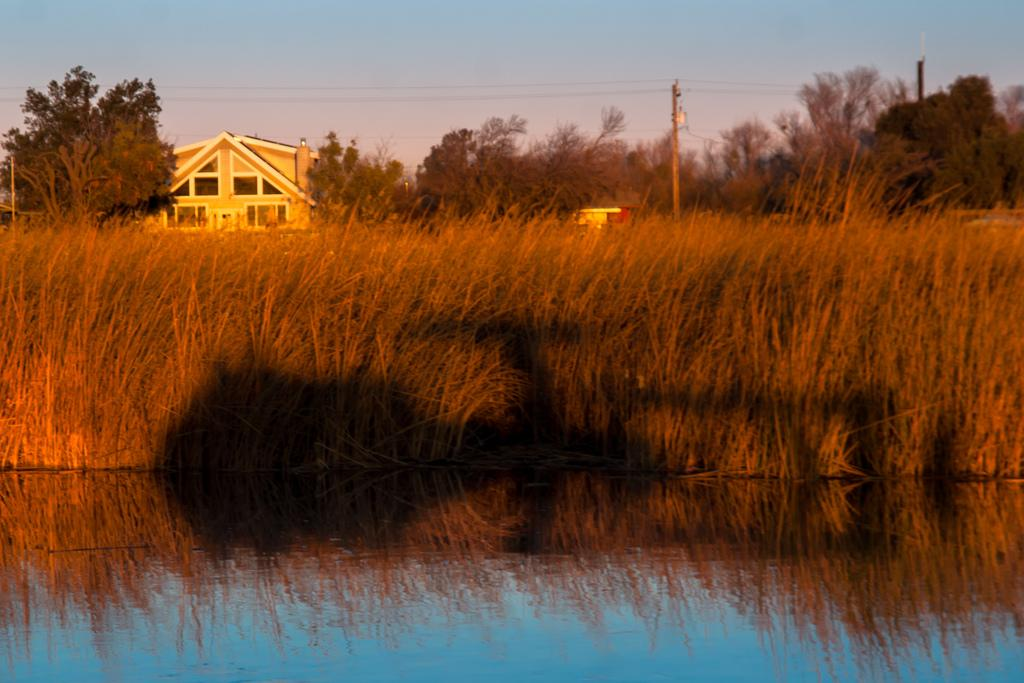What type of structure is visible in the image? There is a building in the image. What natural elements can be seen in the image? There are trees and plants in the water visible in the image. What are the poles used for in the image? The purpose of the poles in the image is not specified, but they could be used for various purposes such as supporting structures or signs. How would you describe the sky in the image? The sky is blue and cloudy in the image. Can you tell me how many experts are present in the image? There is no mention of experts in the image, so it is not possible to determine their presence or number. What type of parcel is floating in the water in the image? There is no parcel visible in the image; it only shows trees, plants in the water, and a building. 